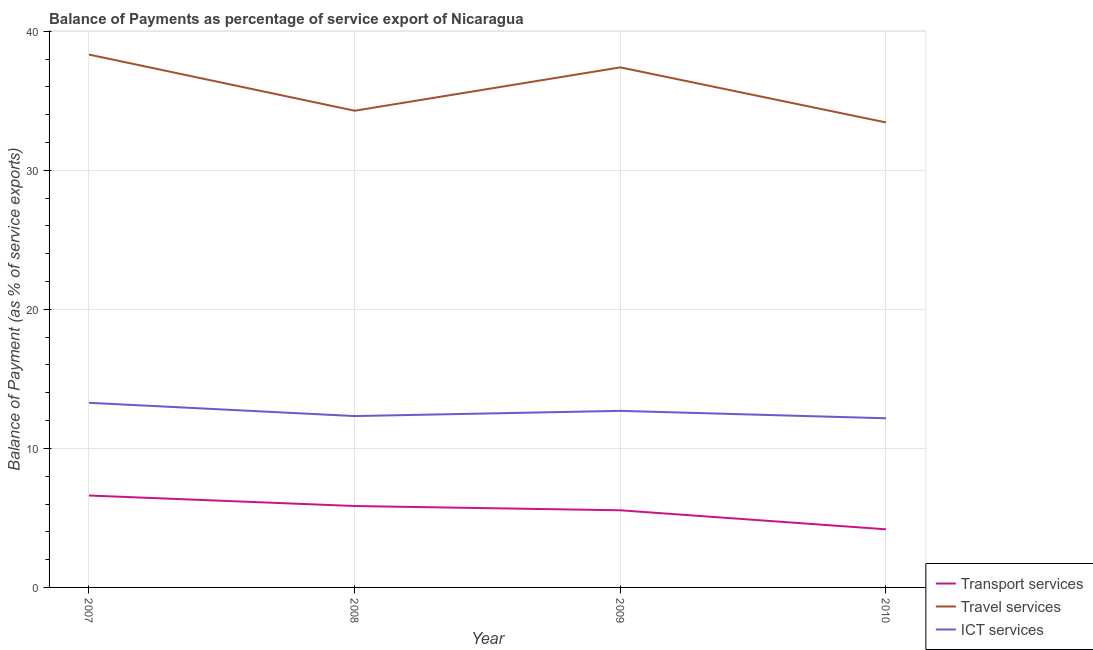What is the balance of payment of ict services in 2009?
Provide a succinct answer. 12.7. Across all years, what is the maximum balance of payment of travel services?
Keep it short and to the point. 38.33. Across all years, what is the minimum balance of payment of transport services?
Keep it short and to the point. 4.18. In which year was the balance of payment of transport services maximum?
Your response must be concise. 2007. What is the total balance of payment of travel services in the graph?
Offer a very short reply. 143.46. What is the difference between the balance of payment of travel services in 2008 and that in 2009?
Provide a short and direct response. -3.12. What is the difference between the balance of payment of ict services in 2007 and the balance of payment of transport services in 2009?
Provide a short and direct response. 7.73. What is the average balance of payment of ict services per year?
Give a very brief answer. 12.62. In the year 2007, what is the difference between the balance of payment of ict services and balance of payment of transport services?
Provide a short and direct response. 6.67. What is the ratio of the balance of payment of travel services in 2008 to that in 2010?
Provide a short and direct response. 1.03. Is the balance of payment of travel services in 2008 less than that in 2009?
Keep it short and to the point. Yes. Is the difference between the balance of payment of ict services in 2007 and 2008 greater than the difference between the balance of payment of transport services in 2007 and 2008?
Your answer should be very brief. Yes. What is the difference between the highest and the second highest balance of payment of transport services?
Your response must be concise. 0.76. What is the difference between the highest and the lowest balance of payment of transport services?
Offer a terse response. 2.43. In how many years, is the balance of payment of travel services greater than the average balance of payment of travel services taken over all years?
Make the answer very short. 2. Is the sum of the balance of payment of ict services in 2009 and 2010 greater than the maximum balance of payment of transport services across all years?
Give a very brief answer. Yes. Is it the case that in every year, the sum of the balance of payment of transport services and balance of payment of travel services is greater than the balance of payment of ict services?
Offer a terse response. Yes. How many lines are there?
Ensure brevity in your answer.  3. What is the difference between two consecutive major ticks on the Y-axis?
Ensure brevity in your answer.  10. Does the graph contain any zero values?
Keep it short and to the point. No. Does the graph contain grids?
Provide a succinct answer. Yes. Where does the legend appear in the graph?
Give a very brief answer. Bottom right. How many legend labels are there?
Make the answer very short. 3. How are the legend labels stacked?
Offer a terse response. Vertical. What is the title of the graph?
Your answer should be compact. Balance of Payments as percentage of service export of Nicaragua. Does "Private sector" appear as one of the legend labels in the graph?
Keep it short and to the point. No. What is the label or title of the Y-axis?
Your answer should be compact. Balance of Payment (as % of service exports). What is the Balance of Payment (as % of service exports) of Transport services in 2007?
Keep it short and to the point. 6.61. What is the Balance of Payment (as % of service exports) in Travel services in 2007?
Your response must be concise. 38.33. What is the Balance of Payment (as % of service exports) of ICT services in 2007?
Offer a terse response. 13.28. What is the Balance of Payment (as % of service exports) of Transport services in 2008?
Provide a short and direct response. 5.85. What is the Balance of Payment (as % of service exports) of Travel services in 2008?
Your answer should be compact. 34.29. What is the Balance of Payment (as % of service exports) in ICT services in 2008?
Your answer should be compact. 12.32. What is the Balance of Payment (as % of service exports) in Transport services in 2009?
Offer a very short reply. 5.55. What is the Balance of Payment (as % of service exports) in Travel services in 2009?
Provide a succinct answer. 37.4. What is the Balance of Payment (as % of service exports) in ICT services in 2009?
Offer a very short reply. 12.7. What is the Balance of Payment (as % of service exports) in Transport services in 2010?
Your response must be concise. 4.18. What is the Balance of Payment (as % of service exports) in Travel services in 2010?
Your answer should be compact. 33.44. What is the Balance of Payment (as % of service exports) in ICT services in 2010?
Keep it short and to the point. 12.17. Across all years, what is the maximum Balance of Payment (as % of service exports) of Transport services?
Offer a terse response. 6.61. Across all years, what is the maximum Balance of Payment (as % of service exports) in Travel services?
Offer a very short reply. 38.33. Across all years, what is the maximum Balance of Payment (as % of service exports) of ICT services?
Your response must be concise. 13.28. Across all years, what is the minimum Balance of Payment (as % of service exports) in Transport services?
Make the answer very short. 4.18. Across all years, what is the minimum Balance of Payment (as % of service exports) of Travel services?
Make the answer very short. 33.44. Across all years, what is the minimum Balance of Payment (as % of service exports) in ICT services?
Your response must be concise. 12.17. What is the total Balance of Payment (as % of service exports) of Transport services in the graph?
Offer a very short reply. 22.19. What is the total Balance of Payment (as % of service exports) of Travel services in the graph?
Provide a short and direct response. 143.46. What is the total Balance of Payment (as % of service exports) in ICT services in the graph?
Keep it short and to the point. 50.47. What is the difference between the Balance of Payment (as % of service exports) in Transport services in 2007 and that in 2008?
Make the answer very short. 0.76. What is the difference between the Balance of Payment (as % of service exports) of Travel services in 2007 and that in 2008?
Your answer should be compact. 4.04. What is the difference between the Balance of Payment (as % of service exports) of ICT services in 2007 and that in 2008?
Keep it short and to the point. 0.95. What is the difference between the Balance of Payment (as % of service exports) in Travel services in 2007 and that in 2009?
Your answer should be compact. 0.92. What is the difference between the Balance of Payment (as % of service exports) in ICT services in 2007 and that in 2009?
Your answer should be compact. 0.58. What is the difference between the Balance of Payment (as % of service exports) of Transport services in 2007 and that in 2010?
Offer a terse response. 2.43. What is the difference between the Balance of Payment (as % of service exports) in Travel services in 2007 and that in 2010?
Make the answer very short. 4.88. What is the difference between the Balance of Payment (as % of service exports) in ICT services in 2007 and that in 2010?
Your response must be concise. 1.11. What is the difference between the Balance of Payment (as % of service exports) in Transport services in 2008 and that in 2009?
Make the answer very short. 0.31. What is the difference between the Balance of Payment (as % of service exports) in Travel services in 2008 and that in 2009?
Give a very brief answer. -3.12. What is the difference between the Balance of Payment (as % of service exports) in ICT services in 2008 and that in 2009?
Your response must be concise. -0.38. What is the difference between the Balance of Payment (as % of service exports) of Transport services in 2008 and that in 2010?
Make the answer very short. 1.67. What is the difference between the Balance of Payment (as % of service exports) of Travel services in 2008 and that in 2010?
Provide a short and direct response. 0.84. What is the difference between the Balance of Payment (as % of service exports) of ICT services in 2008 and that in 2010?
Your answer should be compact. 0.16. What is the difference between the Balance of Payment (as % of service exports) of Transport services in 2009 and that in 2010?
Make the answer very short. 1.37. What is the difference between the Balance of Payment (as % of service exports) in Travel services in 2009 and that in 2010?
Your response must be concise. 3.96. What is the difference between the Balance of Payment (as % of service exports) in ICT services in 2009 and that in 2010?
Offer a terse response. 0.53. What is the difference between the Balance of Payment (as % of service exports) in Transport services in 2007 and the Balance of Payment (as % of service exports) in Travel services in 2008?
Give a very brief answer. -27.68. What is the difference between the Balance of Payment (as % of service exports) in Transport services in 2007 and the Balance of Payment (as % of service exports) in ICT services in 2008?
Your response must be concise. -5.71. What is the difference between the Balance of Payment (as % of service exports) of Travel services in 2007 and the Balance of Payment (as % of service exports) of ICT services in 2008?
Give a very brief answer. 26. What is the difference between the Balance of Payment (as % of service exports) of Transport services in 2007 and the Balance of Payment (as % of service exports) of Travel services in 2009?
Your answer should be very brief. -30.79. What is the difference between the Balance of Payment (as % of service exports) of Transport services in 2007 and the Balance of Payment (as % of service exports) of ICT services in 2009?
Ensure brevity in your answer.  -6.09. What is the difference between the Balance of Payment (as % of service exports) in Travel services in 2007 and the Balance of Payment (as % of service exports) in ICT services in 2009?
Provide a short and direct response. 25.63. What is the difference between the Balance of Payment (as % of service exports) of Transport services in 2007 and the Balance of Payment (as % of service exports) of Travel services in 2010?
Offer a terse response. -26.83. What is the difference between the Balance of Payment (as % of service exports) of Transport services in 2007 and the Balance of Payment (as % of service exports) of ICT services in 2010?
Your answer should be very brief. -5.56. What is the difference between the Balance of Payment (as % of service exports) of Travel services in 2007 and the Balance of Payment (as % of service exports) of ICT services in 2010?
Provide a short and direct response. 26.16. What is the difference between the Balance of Payment (as % of service exports) in Transport services in 2008 and the Balance of Payment (as % of service exports) in Travel services in 2009?
Make the answer very short. -31.55. What is the difference between the Balance of Payment (as % of service exports) of Transport services in 2008 and the Balance of Payment (as % of service exports) of ICT services in 2009?
Offer a very short reply. -6.85. What is the difference between the Balance of Payment (as % of service exports) in Travel services in 2008 and the Balance of Payment (as % of service exports) in ICT services in 2009?
Ensure brevity in your answer.  21.59. What is the difference between the Balance of Payment (as % of service exports) of Transport services in 2008 and the Balance of Payment (as % of service exports) of Travel services in 2010?
Make the answer very short. -27.59. What is the difference between the Balance of Payment (as % of service exports) in Transport services in 2008 and the Balance of Payment (as % of service exports) in ICT services in 2010?
Make the answer very short. -6.31. What is the difference between the Balance of Payment (as % of service exports) of Travel services in 2008 and the Balance of Payment (as % of service exports) of ICT services in 2010?
Ensure brevity in your answer.  22.12. What is the difference between the Balance of Payment (as % of service exports) in Transport services in 2009 and the Balance of Payment (as % of service exports) in Travel services in 2010?
Provide a succinct answer. -27.9. What is the difference between the Balance of Payment (as % of service exports) of Transport services in 2009 and the Balance of Payment (as % of service exports) of ICT services in 2010?
Your answer should be compact. -6.62. What is the difference between the Balance of Payment (as % of service exports) in Travel services in 2009 and the Balance of Payment (as % of service exports) in ICT services in 2010?
Offer a very short reply. 25.24. What is the average Balance of Payment (as % of service exports) of Transport services per year?
Give a very brief answer. 5.55. What is the average Balance of Payment (as % of service exports) of Travel services per year?
Your answer should be compact. 35.87. What is the average Balance of Payment (as % of service exports) in ICT services per year?
Give a very brief answer. 12.62. In the year 2007, what is the difference between the Balance of Payment (as % of service exports) in Transport services and Balance of Payment (as % of service exports) in Travel services?
Your answer should be compact. -31.72. In the year 2007, what is the difference between the Balance of Payment (as % of service exports) of Transport services and Balance of Payment (as % of service exports) of ICT services?
Make the answer very short. -6.67. In the year 2007, what is the difference between the Balance of Payment (as % of service exports) of Travel services and Balance of Payment (as % of service exports) of ICT services?
Offer a terse response. 25.05. In the year 2008, what is the difference between the Balance of Payment (as % of service exports) of Transport services and Balance of Payment (as % of service exports) of Travel services?
Offer a very short reply. -28.43. In the year 2008, what is the difference between the Balance of Payment (as % of service exports) in Transport services and Balance of Payment (as % of service exports) in ICT services?
Make the answer very short. -6.47. In the year 2008, what is the difference between the Balance of Payment (as % of service exports) in Travel services and Balance of Payment (as % of service exports) in ICT services?
Provide a succinct answer. 21.96. In the year 2009, what is the difference between the Balance of Payment (as % of service exports) in Transport services and Balance of Payment (as % of service exports) in Travel services?
Offer a terse response. -31.86. In the year 2009, what is the difference between the Balance of Payment (as % of service exports) in Transport services and Balance of Payment (as % of service exports) in ICT services?
Provide a succinct answer. -7.15. In the year 2009, what is the difference between the Balance of Payment (as % of service exports) of Travel services and Balance of Payment (as % of service exports) of ICT services?
Offer a terse response. 24.7. In the year 2010, what is the difference between the Balance of Payment (as % of service exports) of Transport services and Balance of Payment (as % of service exports) of Travel services?
Keep it short and to the point. -29.26. In the year 2010, what is the difference between the Balance of Payment (as % of service exports) of Transport services and Balance of Payment (as % of service exports) of ICT services?
Offer a terse response. -7.99. In the year 2010, what is the difference between the Balance of Payment (as % of service exports) in Travel services and Balance of Payment (as % of service exports) in ICT services?
Your response must be concise. 21.28. What is the ratio of the Balance of Payment (as % of service exports) in Transport services in 2007 to that in 2008?
Offer a very short reply. 1.13. What is the ratio of the Balance of Payment (as % of service exports) in Travel services in 2007 to that in 2008?
Your answer should be very brief. 1.12. What is the ratio of the Balance of Payment (as % of service exports) of ICT services in 2007 to that in 2008?
Offer a very short reply. 1.08. What is the ratio of the Balance of Payment (as % of service exports) of Transport services in 2007 to that in 2009?
Your response must be concise. 1.19. What is the ratio of the Balance of Payment (as % of service exports) of Travel services in 2007 to that in 2009?
Keep it short and to the point. 1.02. What is the ratio of the Balance of Payment (as % of service exports) of ICT services in 2007 to that in 2009?
Provide a short and direct response. 1.05. What is the ratio of the Balance of Payment (as % of service exports) in Transport services in 2007 to that in 2010?
Offer a very short reply. 1.58. What is the ratio of the Balance of Payment (as % of service exports) in Travel services in 2007 to that in 2010?
Make the answer very short. 1.15. What is the ratio of the Balance of Payment (as % of service exports) in ICT services in 2007 to that in 2010?
Give a very brief answer. 1.09. What is the ratio of the Balance of Payment (as % of service exports) of Transport services in 2008 to that in 2009?
Give a very brief answer. 1.06. What is the ratio of the Balance of Payment (as % of service exports) of Travel services in 2008 to that in 2009?
Give a very brief answer. 0.92. What is the ratio of the Balance of Payment (as % of service exports) in ICT services in 2008 to that in 2009?
Ensure brevity in your answer.  0.97. What is the ratio of the Balance of Payment (as % of service exports) of Transport services in 2008 to that in 2010?
Your response must be concise. 1.4. What is the ratio of the Balance of Payment (as % of service exports) in Travel services in 2008 to that in 2010?
Keep it short and to the point. 1.03. What is the ratio of the Balance of Payment (as % of service exports) in Transport services in 2009 to that in 2010?
Keep it short and to the point. 1.33. What is the ratio of the Balance of Payment (as % of service exports) of Travel services in 2009 to that in 2010?
Your answer should be very brief. 1.12. What is the ratio of the Balance of Payment (as % of service exports) of ICT services in 2009 to that in 2010?
Your answer should be compact. 1.04. What is the difference between the highest and the second highest Balance of Payment (as % of service exports) in Transport services?
Provide a short and direct response. 0.76. What is the difference between the highest and the second highest Balance of Payment (as % of service exports) in Travel services?
Your response must be concise. 0.92. What is the difference between the highest and the second highest Balance of Payment (as % of service exports) of ICT services?
Ensure brevity in your answer.  0.58. What is the difference between the highest and the lowest Balance of Payment (as % of service exports) of Transport services?
Provide a succinct answer. 2.43. What is the difference between the highest and the lowest Balance of Payment (as % of service exports) of Travel services?
Your answer should be very brief. 4.88. What is the difference between the highest and the lowest Balance of Payment (as % of service exports) of ICT services?
Offer a terse response. 1.11. 